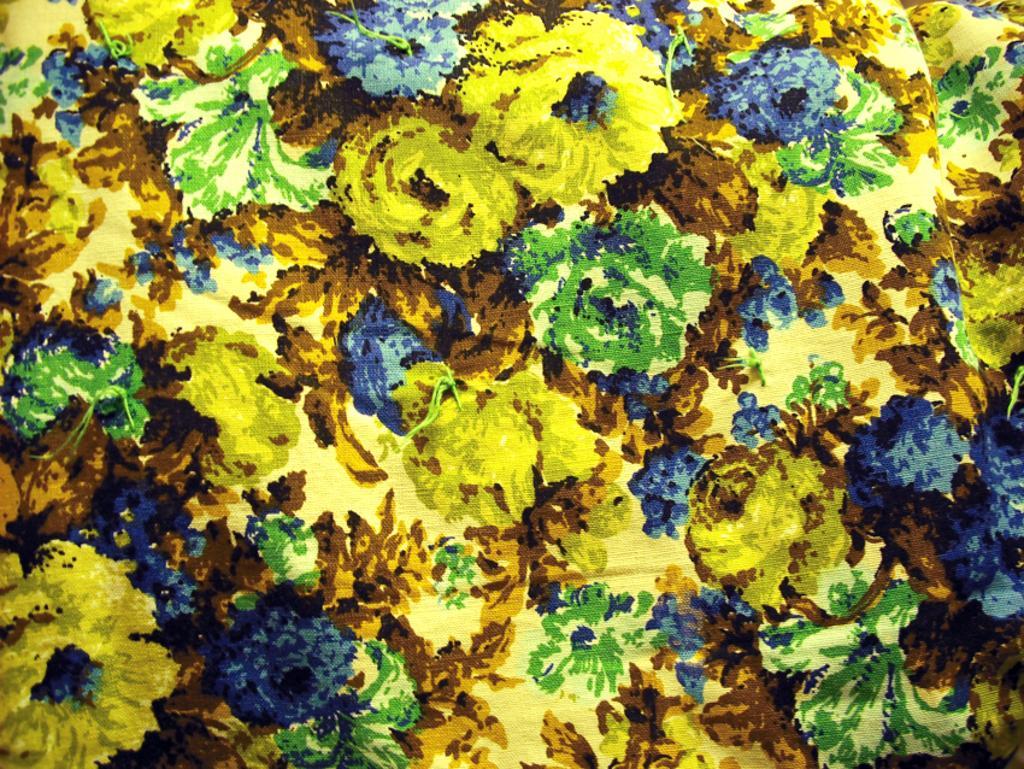Please provide a concise description of this image. This is an art in yellow, green and blue color. 